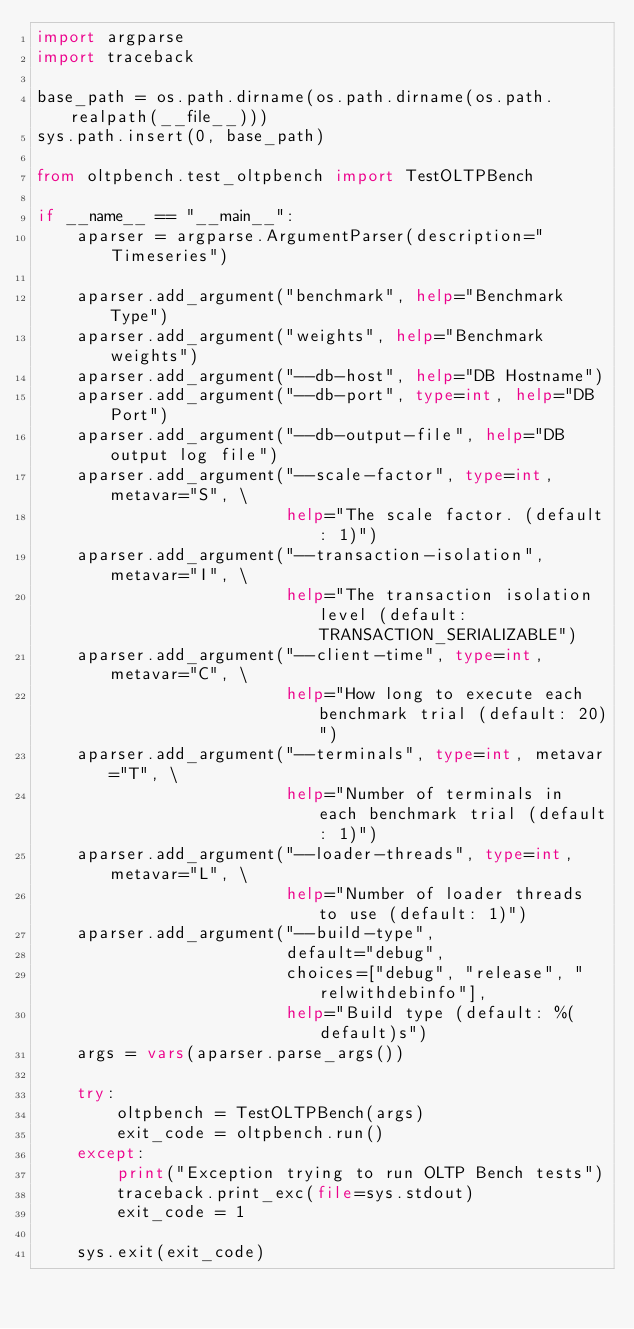Convert code to text. <code><loc_0><loc_0><loc_500><loc_500><_Python_>import argparse
import traceback

base_path = os.path.dirname(os.path.dirname(os.path.realpath(__file__)))
sys.path.insert(0, base_path)

from oltpbench.test_oltpbench import TestOLTPBench

if __name__ == "__main__":
    aparser = argparse.ArgumentParser(description="Timeseries")

    aparser.add_argument("benchmark", help="Benchmark Type")
    aparser.add_argument("weights", help="Benchmark weights")
    aparser.add_argument("--db-host", help="DB Hostname")
    aparser.add_argument("--db-port", type=int, help="DB Port")
    aparser.add_argument("--db-output-file", help="DB output log file")
    aparser.add_argument("--scale-factor", type=int, metavar="S", \
                         help="The scale factor. (default: 1)")
    aparser.add_argument("--transaction-isolation", metavar="I", \
                         help="The transaction isolation level (default: TRANSACTION_SERIALIZABLE")
    aparser.add_argument("--client-time", type=int, metavar="C", \
                         help="How long to execute each benchmark trial (default: 20)")
    aparser.add_argument("--terminals", type=int, metavar="T", \
                         help="Number of terminals in each benchmark trial (default: 1)")
    aparser.add_argument("--loader-threads", type=int, metavar="L", \
                         help="Number of loader threads to use (default: 1)")
    aparser.add_argument("--build-type",
                         default="debug",
                         choices=["debug", "release", "relwithdebinfo"],
                         help="Build type (default: %(default)s")
    args = vars(aparser.parse_args())

    try:
        oltpbench = TestOLTPBench(args)
        exit_code = oltpbench.run()
    except:
        print("Exception trying to run OLTP Bench tests")
        traceback.print_exc(file=sys.stdout)
        exit_code = 1

    sys.exit(exit_code)
</code> 